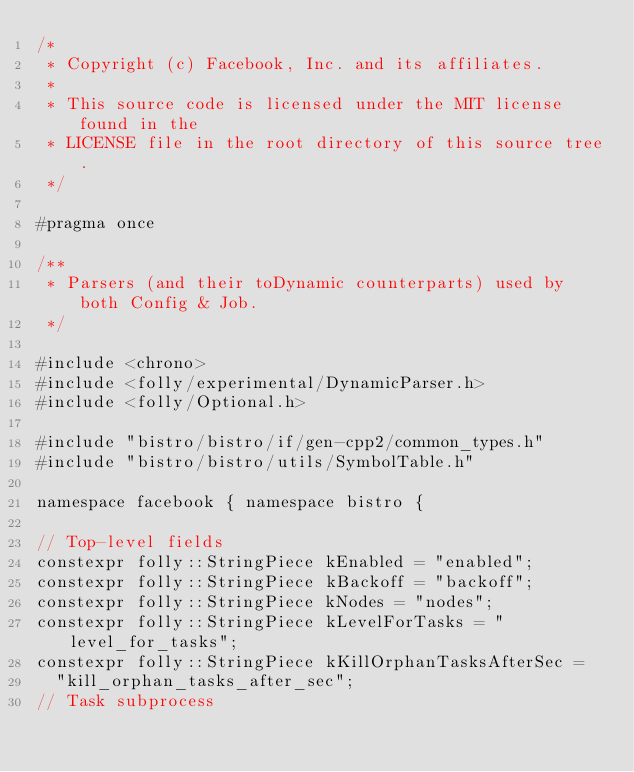<code> <loc_0><loc_0><loc_500><loc_500><_C_>/*
 * Copyright (c) Facebook, Inc. and its affiliates.
 *
 * This source code is licensed under the MIT license found in the
 * LICENSE file in the root directory of this source tree.
 */

#pragma once

/**
 * Parsers (and their toDynamic counterparts) used by both Config & Job.
 */

#include <chrono>
#include <folly/experimental/DynamicParser.h>
#include <folly/Optional.h>

#include "bistro/bistro/if/gen-cpp2/common_types.h"
#include "bistro/bistro/utils/SymbolTable.h"

namespace facebook { namespace bistro {

// Top-level fields
constexpr folly::StringPiece kEnabled = "enabled";
constexpr folly::StringPiece kBackoff = "backoff";
constexpr folly::StringPiece kNodes = "nodes";
constexpr folly::StringPiece kLevelForTasks = "level_for_tasks";
constexpr folly::StringPiece kKillOrphanTasksAfterSec =
  "kill_orphan_tasks_after_sec";
// Task subprocess</code> 